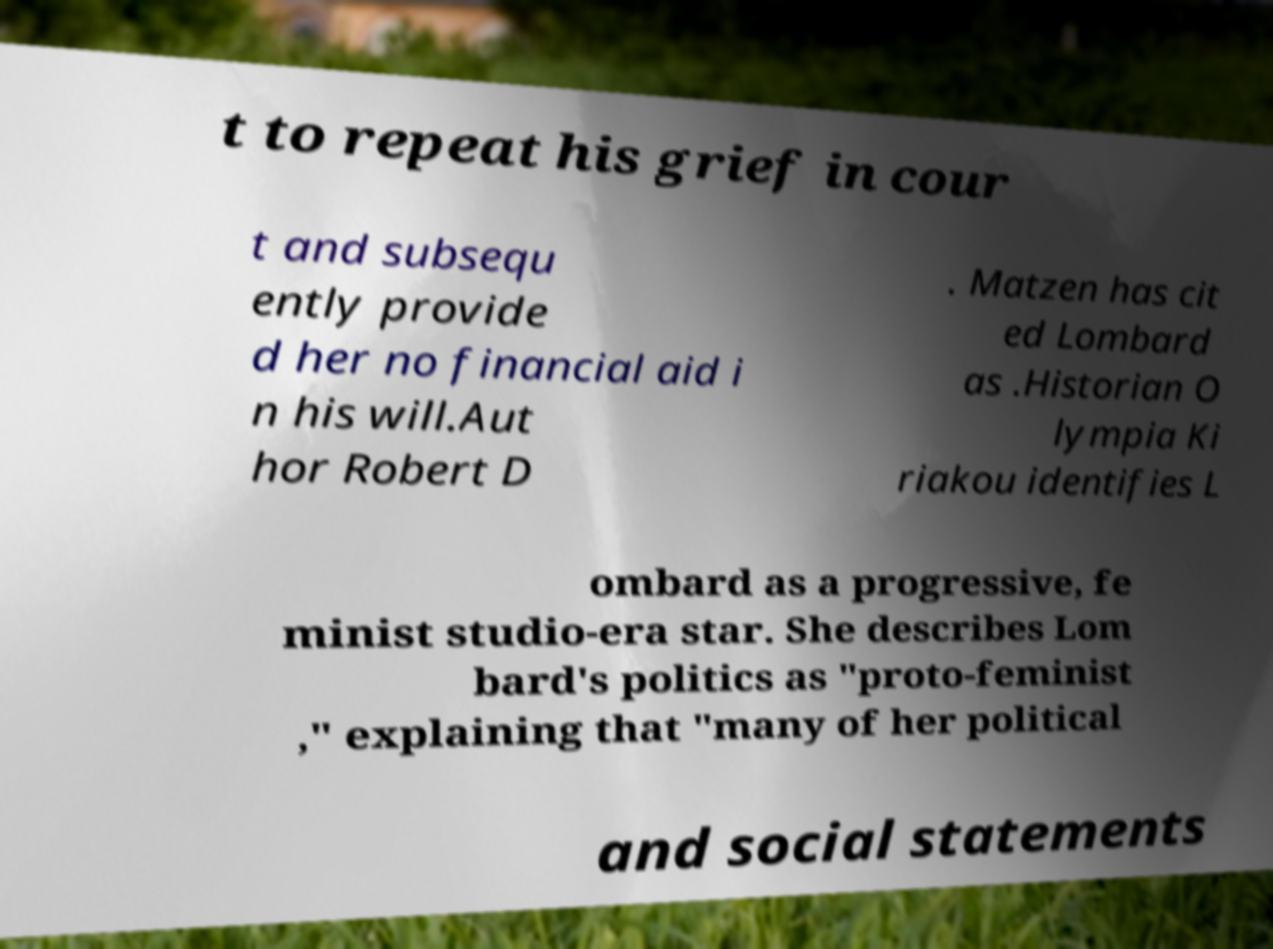Could you extract and type out the text from this image? t to repeat his grief in cour t and subsequ ently provide d her no financial aid i n his will.Aut hor Robert D . Matzen has cit ed Lombard as .Historian O lympia Ki riakou identifies L ombard as a progressive, fe minist studio-era star. She describes Lom bard's politics as "proto-feminist ," explaining that "many of her political and social statements 